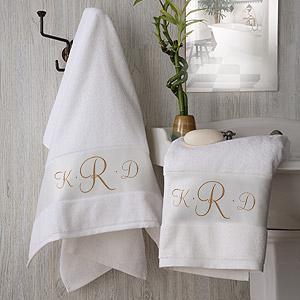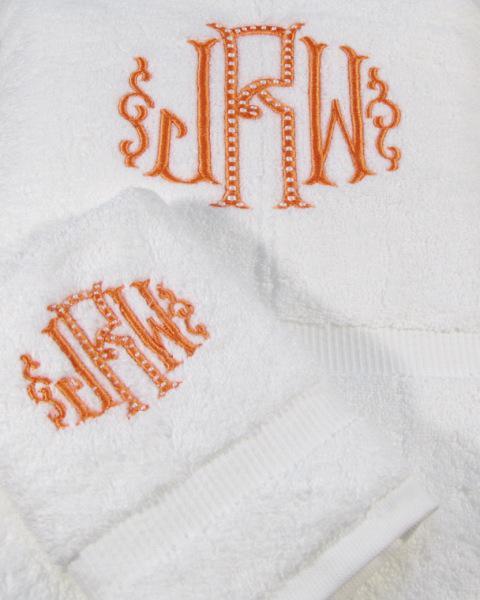The first image is the image on the left, the second image is the image on the right. For the images shown, is this caption "There is at least one towel that is primarily a pinkish hue in color" true? Answer yes or no. No. The first image is the image on the left, the second image is the image on the right. Examine the images to the left and right. Is the description "The middle letter in the monogram on several of the towels is a capital R." accurate? Answer yes or no. Yes. 